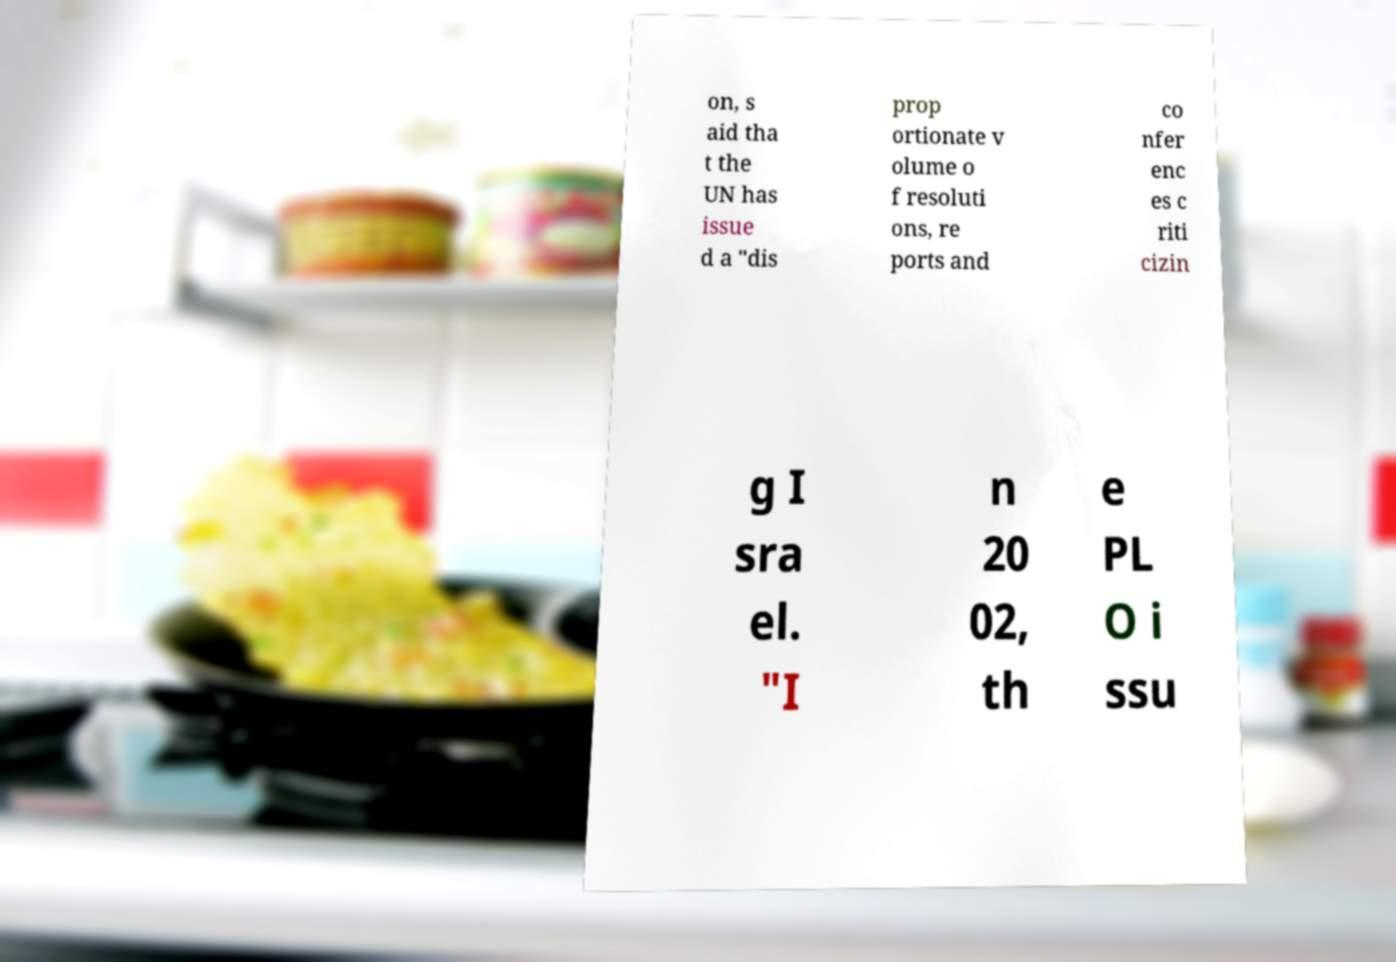Can you read and provide the text displayed in the image?This photo seems to have some interesting text. Can you extract and type it out for me? on, s aid tha t the UN has issue d a "dis prop ortionate v olume o f resoluti ons, re ports and co nfer enc es c riti cizin g I sra el. "I n 20 02, th e PL O i ssu 